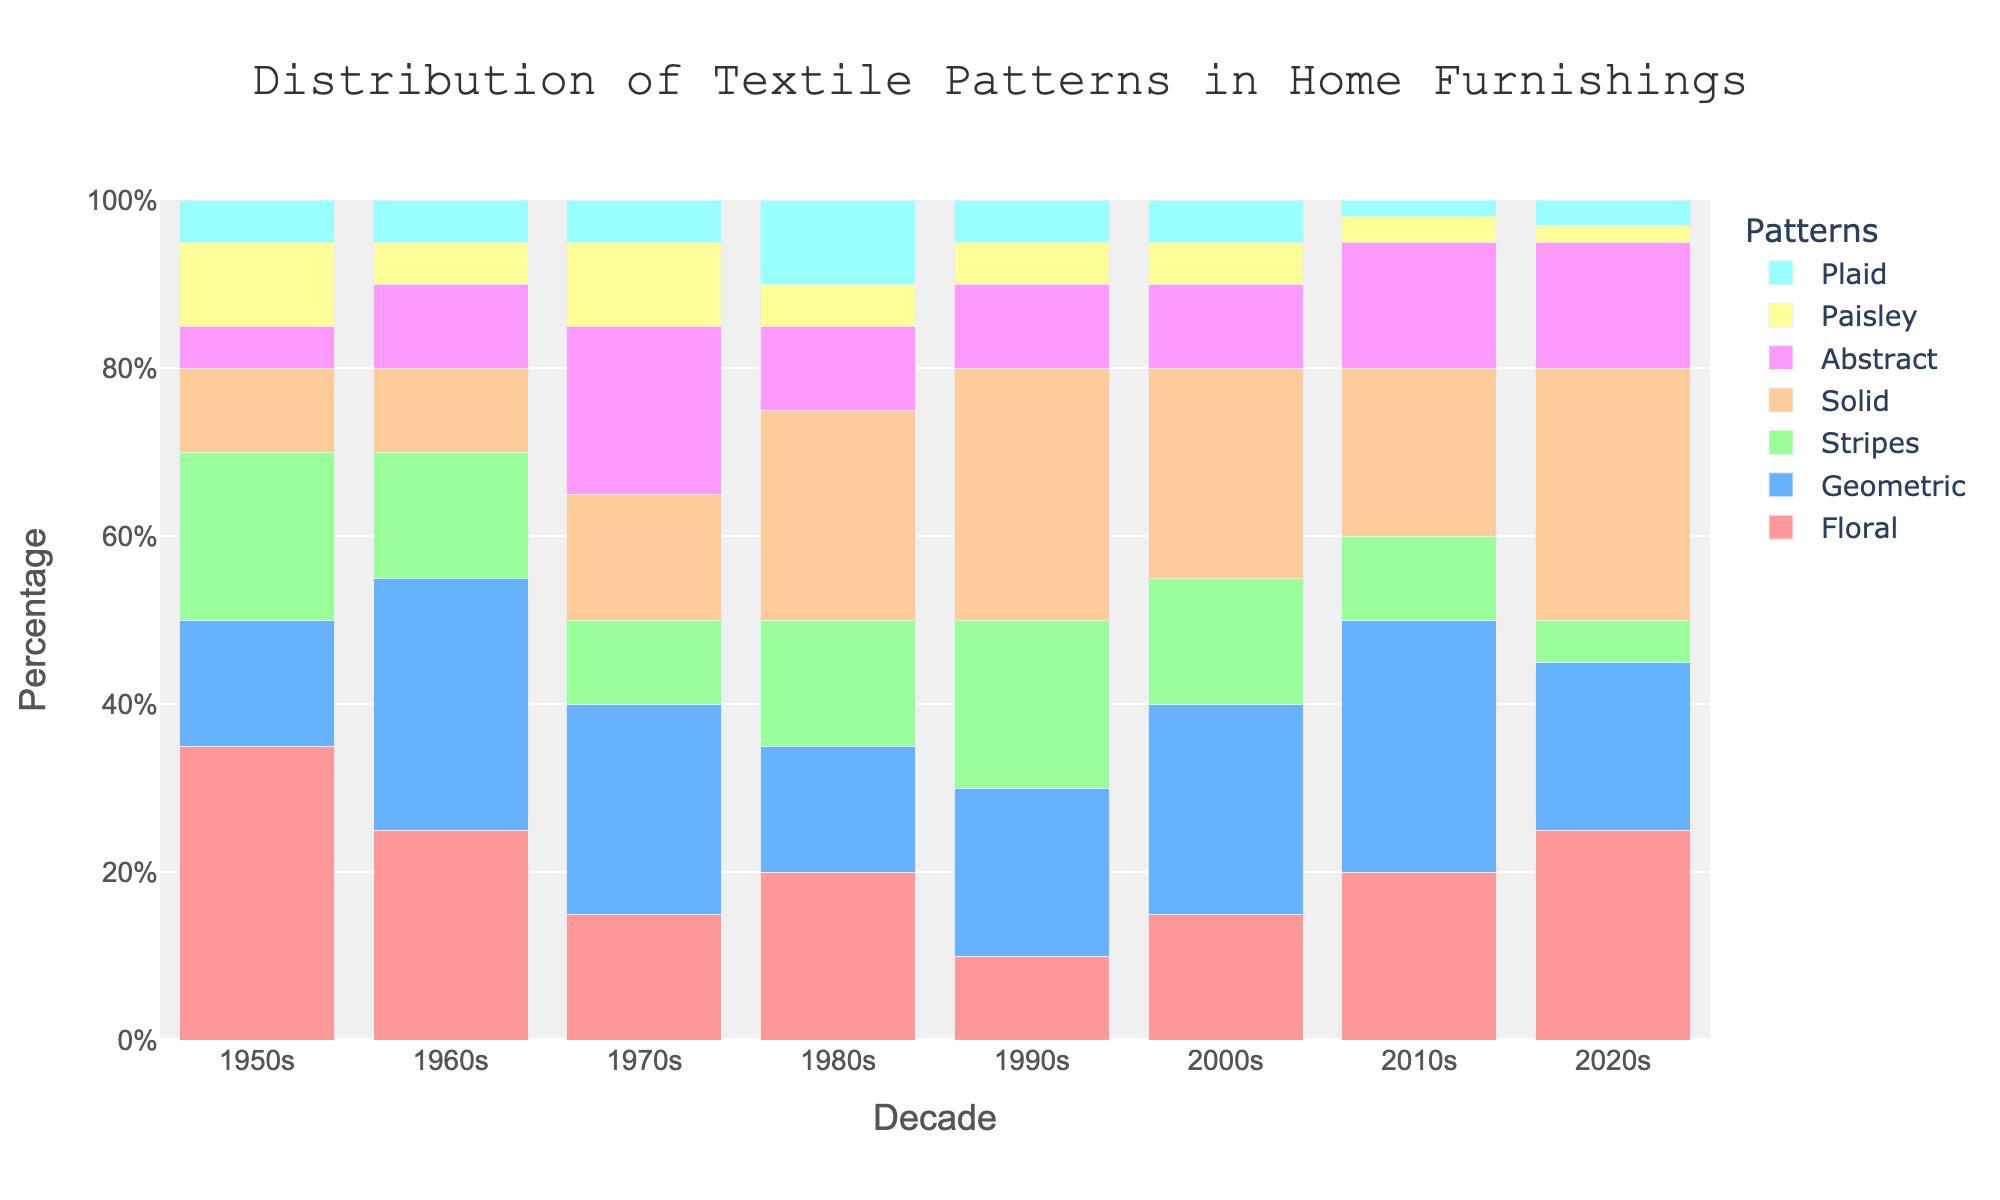Which decade had the highest percentage of floral patterns? The highest bar for floral patterns corresponds to the 1950s.
Answer: 1950s What is the total percentage of geometric patterns across all decades? Sum the percentages of geometric patterns for each decade: 15 + 30 + 25 + 15 + 20 + 25 + 30 + 20 = 180
Answer: 180% Which pattern had the least percentage in the 2020s? The shortest bar in the 2020s is for Paisley, with only 2%.
Answer: Paisley In which decade did solid patterns have the highest percentage? The highest bar for solid patterns corresponds to the 2020s.
Answer: 2020s What is the difference in the percentage of geometric patterns between the 1960s and 1970s? Subtract the value of geometric patterns in the 1970s (25) from the value in the 1960s (30): 30 - 25 = 5
Answer: 5% Which decade had a similar percentage for floral and abstract patterns? The 2010s have similar percentages for floral (20) and abstract (15) patterns.
Answer: 2010s What is the average percentage of stripes patterns across all decades? Sum the percentage values for stripes across all decades and divide by the number of decades: (20 + 15 + 10 + 15 + 20 + 15 + 10 + 5) / 8 = 13.125
Answer: 13.125% Which decade had the most balanced distribution of all patterns? The decade with bars of more similar heights across all patterns is the 1970s.
Answer: 1970s What is the percentage difference of plaids between the 1950s and the 2020s? Subtract the value of plaids in the 1950s (5) from the value in the 2020s (3): 5 - 3 = 2
Answer: 2% Which pattern increased in popularity from the 1950s to the 2000s? By comparing the heights of bars, geometric patterns increased from 15% in the 1950s to 25% in the 2000s.
Answer: Geometric 